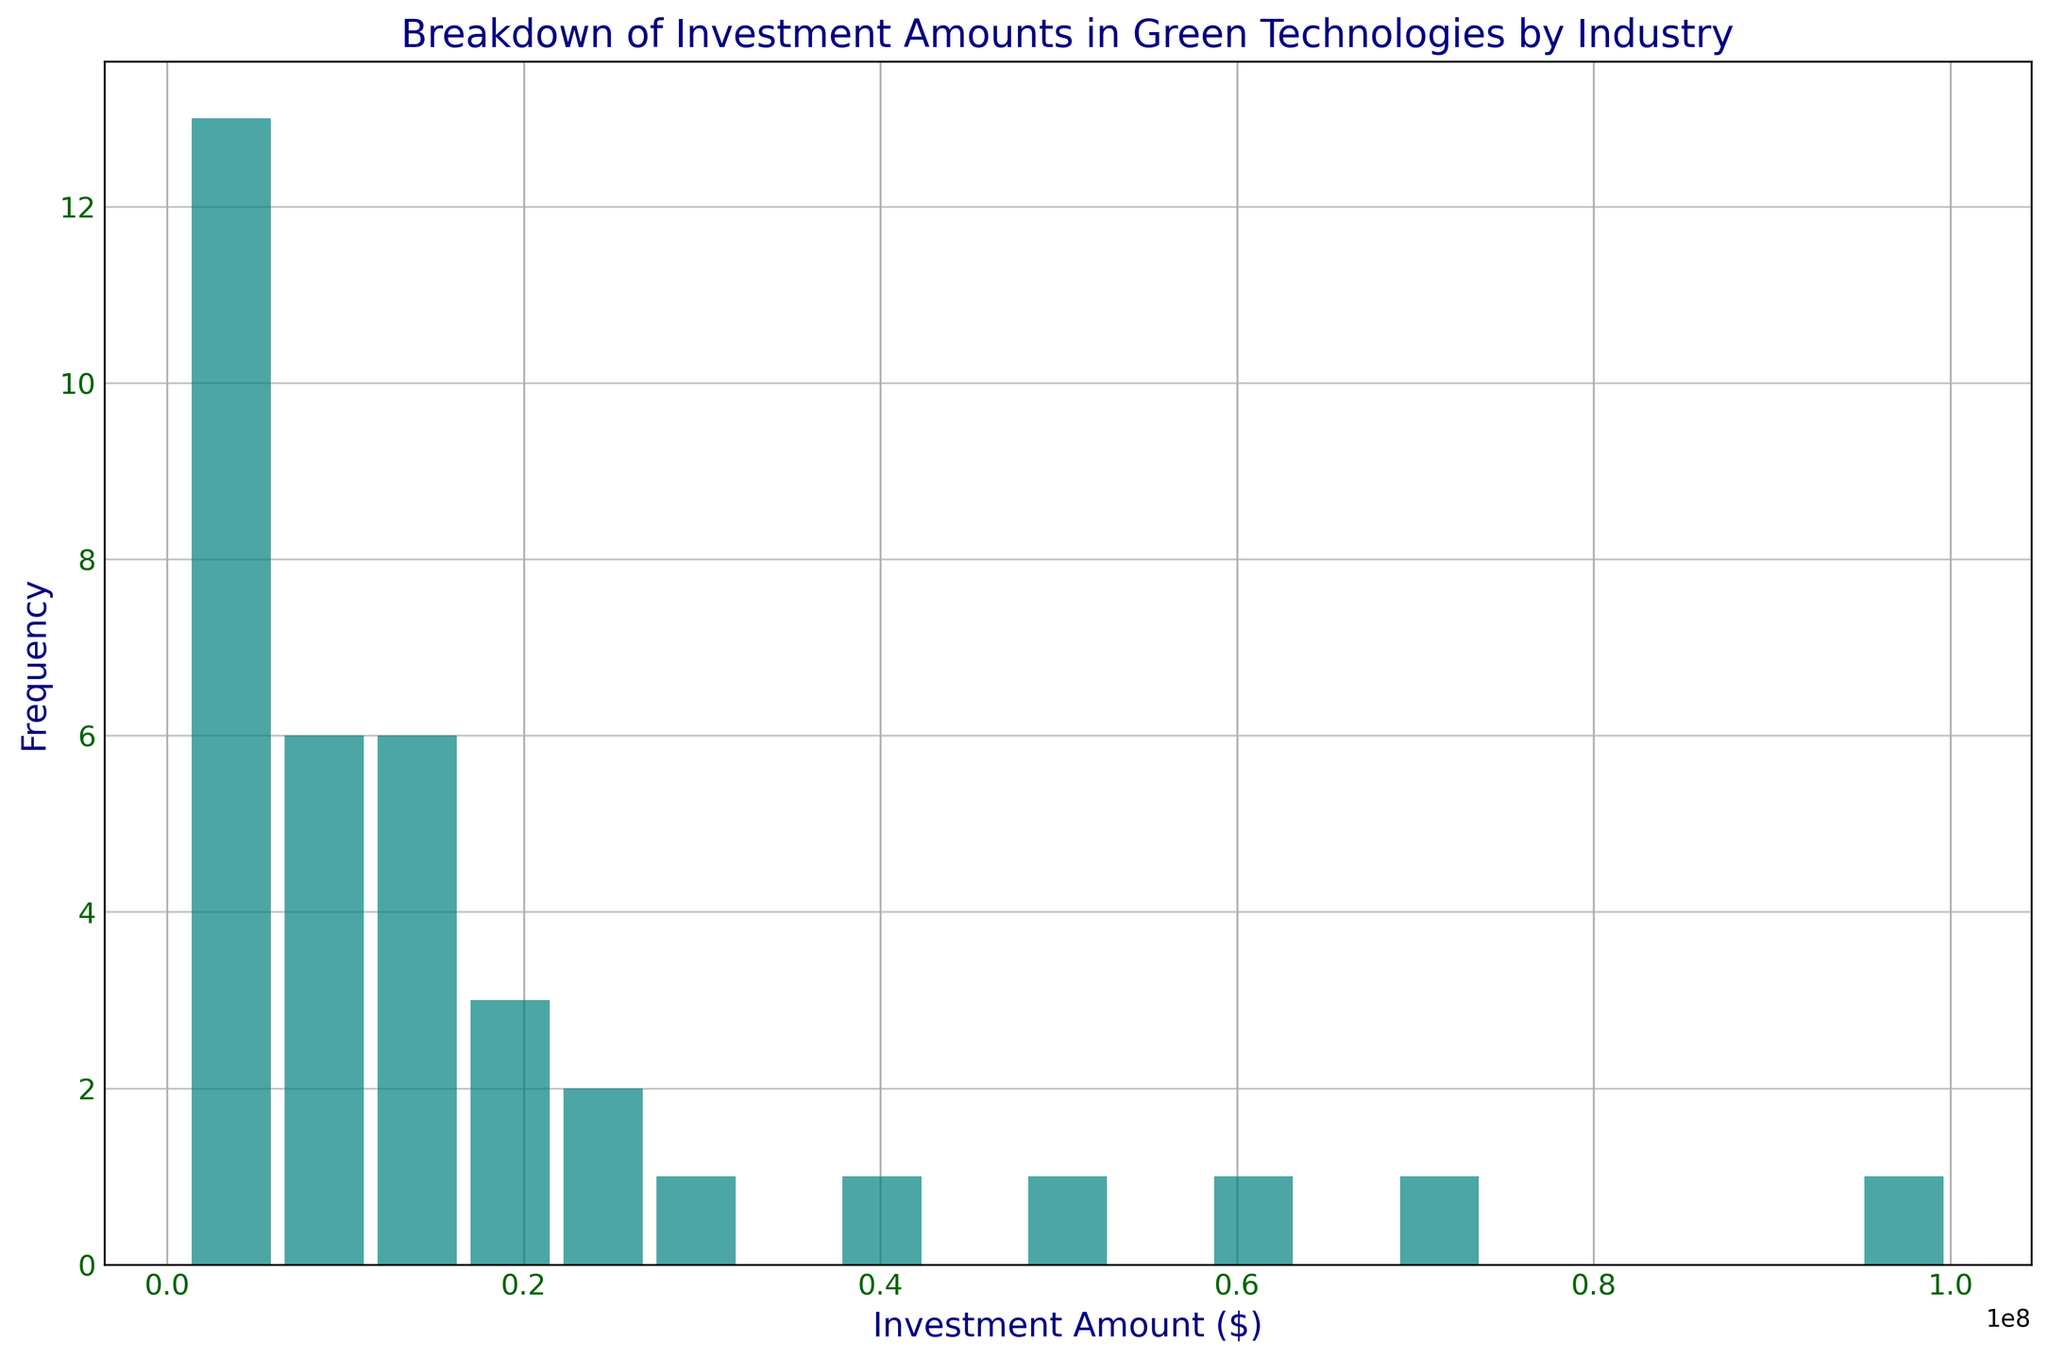What is the most frequent investment range in the industries? Look for the investment amount bins with the highest bars in the histogram. These indicate the range with the most frequent investments.
Answer: $12M - $20M What is the least frequent investment range in the industries? Identify the investment amount bins with the lowest bars in the histogram. This will indicate the range with the least frequency.
Answer: $72M - $80M Which industry appears to have the highest investment amounts? The histogram bins with the highest investment amounts are likely dominated by a particular industry. By knowing the investment data, you can infer which industry corresponds to those bins.
Answer: Energy What is the general trend in investment amounts as the value increases? Observe the pattern of the bars as investment amounts increase along the x-axis. Determine whether the bars generally increase, decrease, or remain constant.
Answer: Decrease Are there any noticeable investment patterns in the range of $0M to $20M? Focus on the histogram bars within the $0M to $20M range to identify any specific trends, increases, or decreases.
Answer: Higher frequency What industries can you infer are associated with lower investment amounts? Based on known industry investment amounts from the dataset, associate frequent low investment amount bins with industries.
Answer: Agriculture, Education, Retail How does the frequency of investments change between $40M and $60M compared to $60M and $80M? Compare the height of the bars in the two specified investment ranges to see if the frequency increases, decreases, or remains the same.
Answer: Decreases What is the average investment amount inferred from the visual data? Estimate the central tendency by observing the spread of the histogram and identifying the approximate center of the range of investment amounts.
Answer: ~$20M - $25M Which industry appears less frequently in higher investment bins above $20M? Check which notable industries have lower representation in the higher investment amount bars.
Answer: Most industries other than Energy and Manufacturing 